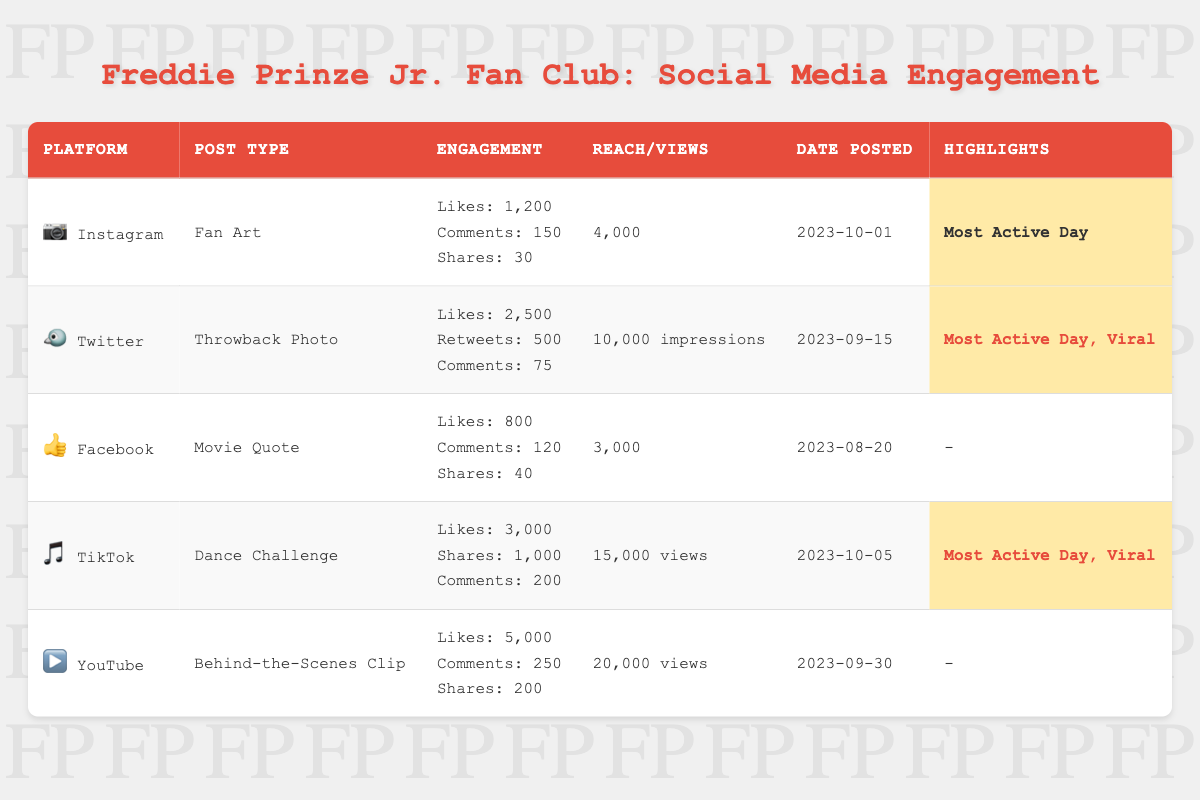What is the most liked post type on social media for Freddie Prinze Jr.? The post with the highest likes is on YouTube, which has 5,000 likes for the "Behind-the-Scenes Clip".
Answer: 5,000 likes Which platform had the highest number of shares? The TikTok post has the highest shares, totaling 1,000 shares for the "Dance Challenge".
Answer: TikTok How many total likes are there for all the posts featuring Freddie Prinze Jr.? The total likes can be calculated by adding across all posts: 1,200 (Instagram) + 2,500 (Twitter) + 800 (Facebook) + 3,000 (TikTok) + 5,000 (YouTube) = 12,500 likes.
Answer: 12,500 likes Does the Facebook post feature any highlights? The Facebook post does not have any highlights marked; it specifically says "-".
Answer: No Which post types are labeled as "most active day"? The posts labeled as "most active day" are from Instagram, Twitter, and TikTok, with their respective post types being "Fan Art", "Throwback Photo", and "Dance Challenge".
Answer: Instagram, Twitter, TikTok What is the average number of comments across all posts? To find the average number of comments, first sum up the comments: 150 (Instagram) + 75 (Twitter) + 120 (Facebook) + 200 (TikTok) + 250 (YouTube) = 795. Then divide by the number of posts, which is 5: 795 / 5 = 159.
Answer: 159 comments Is there any post that is both viral and posted on the most active day? Yes, the TikTok post ("Dance Challenge") and the Twitter post ("Throwback Photo") are both labeled as viral and were posted on the most active day.
Answer: Yes Which platform received the least engagement based on likes and comments? By comparing the total engagement (likes + comments) for each platform, Facebook has the least engagement: 800 likes + 120 comments = 920.
Answer: Facebook What is the difference in views between the TikTok post and the YouTube post? The difference in views is calculated by subtracting YouTube views from TikTok views: 15,000 (TikTok) - 20,000 (YouTube) = -5,000, which indicates YouTube had more views.
Answer: -5,000 views How many posts are categorized as viral? There are two posts categorized as viral: the Twitter post and the TikTok post.
Answer: 2 posts 